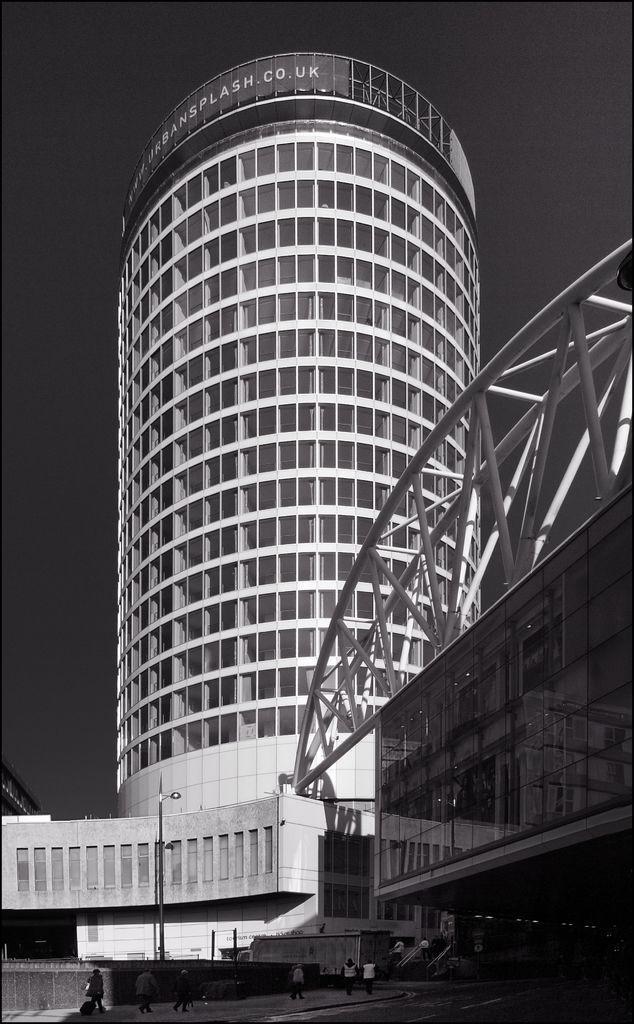Can you describe this image briefly? In this image we can see the buildings and glass windows, metal frame, few people, street light, at the top we can see the sky. 